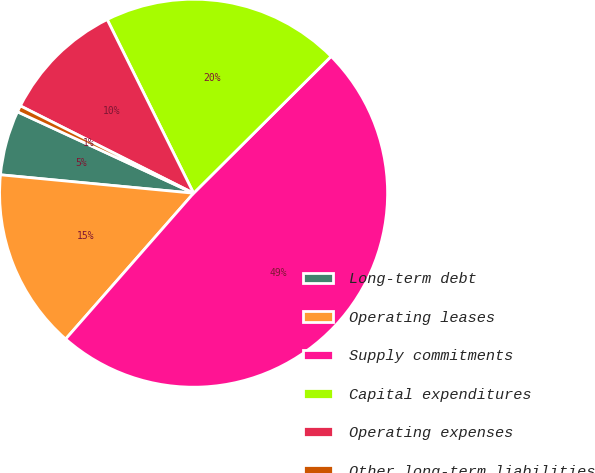Convert chart to OTSL. <chart><loc_0><loc_0><loc_500><loc_500><pie_chart><fcel>Long-term debt<fcel>Operating leases<fcel>Supply commitments<fcel>Capital expenditures<fcel>Operating expenses<fcel>Other long-term liabilities<nl><fcel>5.38%<fcel>15.05%<fcel>48.92%<fcel>19.89%<fcel>10.22%<fcel>0.54%<nl></chart> 